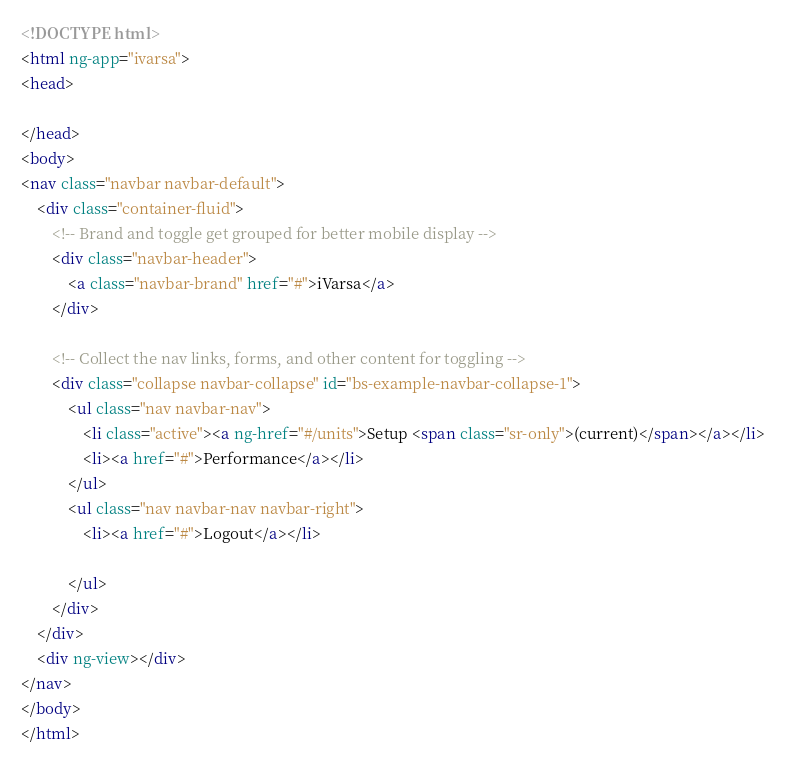Convert code to text. <code><loc_0><loc_0><loc_500><loc_500><_HTML_><!DOCTYPE html>
<html ng-app="ivarsa">
<head>

</head>
<body>
<nav class="navbar navbar-default">
    <div class="container-fluid">
        <!-- Brand and toggle get grouped for better mobile display -->
        <div class="navbar-header">
            <a class="navbar-brand" href="#">iVarsa</a>
        </div>

        <!-- Collect the nav links, forms, and other content for toggling -->
        <div class="collapse navbar-collapse" id="bs-example-navbar-collapse-1">
            <ul class="nav navbar-nav">
                <li class="active"><a ng-href="#/units">Setup <span class="sr-only">(current)</span></a></li>
                <li><a href="#">Performance</a></li>
            </ul>
            <ul class="nav navbar-nav navbar-right">
                <li><a href="#">Logout</a></li>

            </ul>
        </div>
    </div>
    <div ng-view></div>
</nav>
</body>
</html></code> 